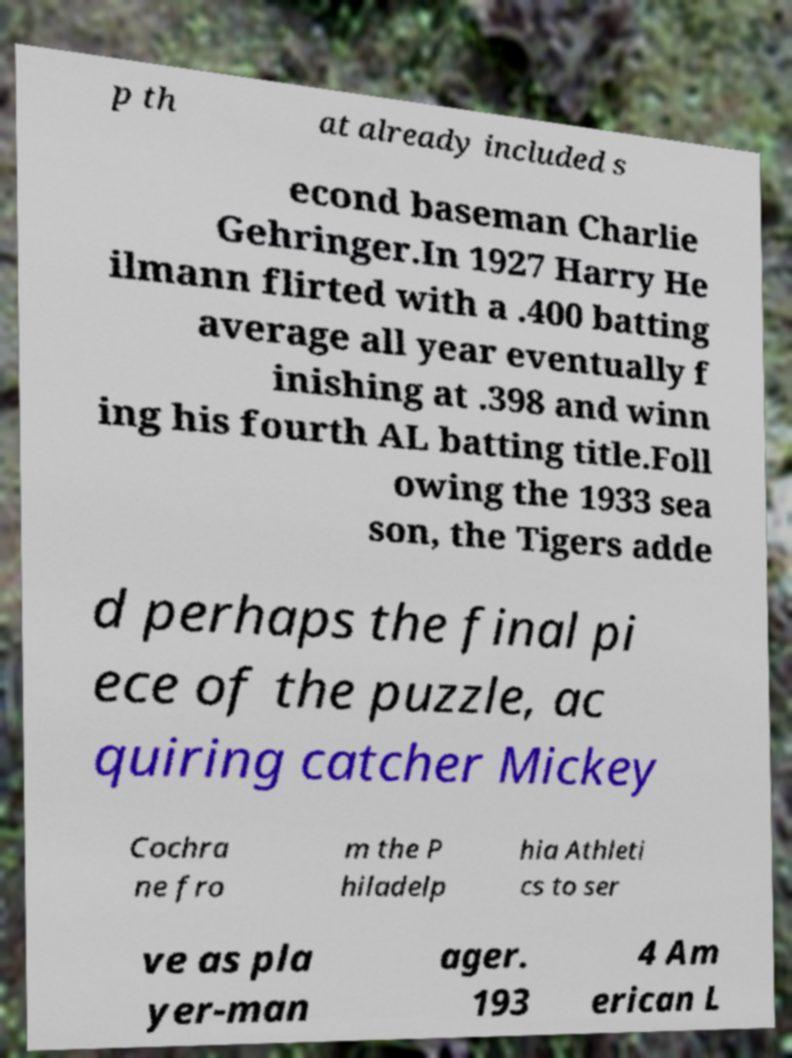Can you read and provide the text displayed in the image?This photo seems to have some interesting text. Can you extract and type it out for me? p th at already included s econd baseman Charlie Gehringer.In 1927 Harry He ilmann flirted with a .400 batting average all year eventually f inishing at .398 and winn ing his fourth AL batting title.Foll owing the 1933 sea son, the Tigers adde d perhaps the final pi ece of the puzzle, ac quiring catcher Mickey Cochra ne fro m the P hiladelp hia Athleti cs to ser ve as pla yer-man ager. 193 4 Am erican L 